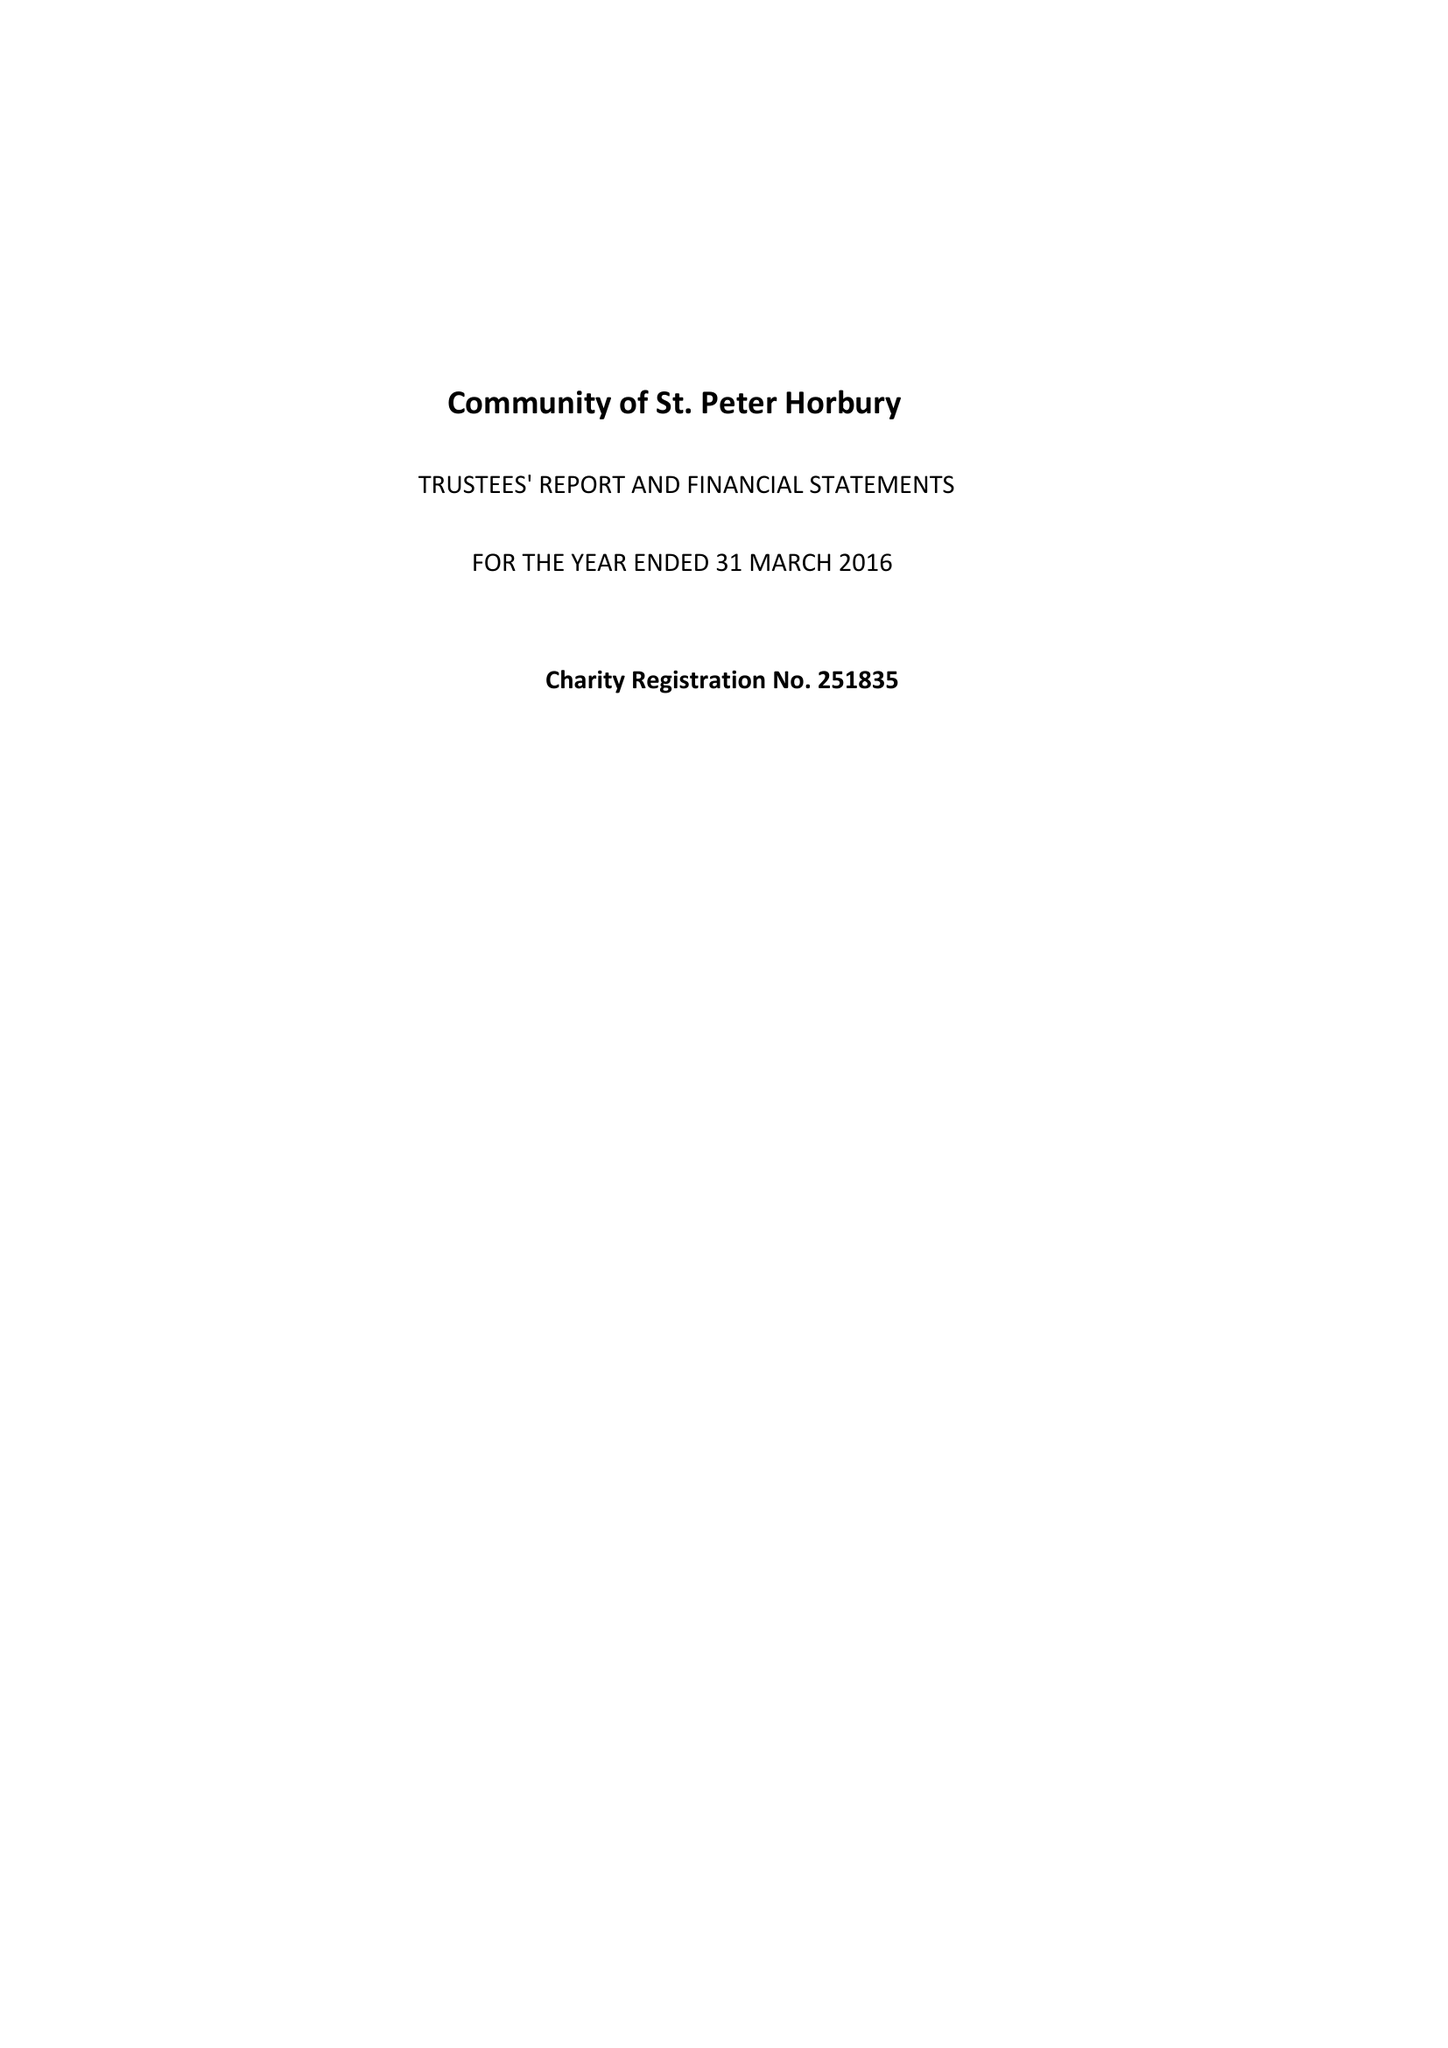What is the value for the address__street_line?
Answer the question using a single word or phrase. 14 SPRING END ROAD 